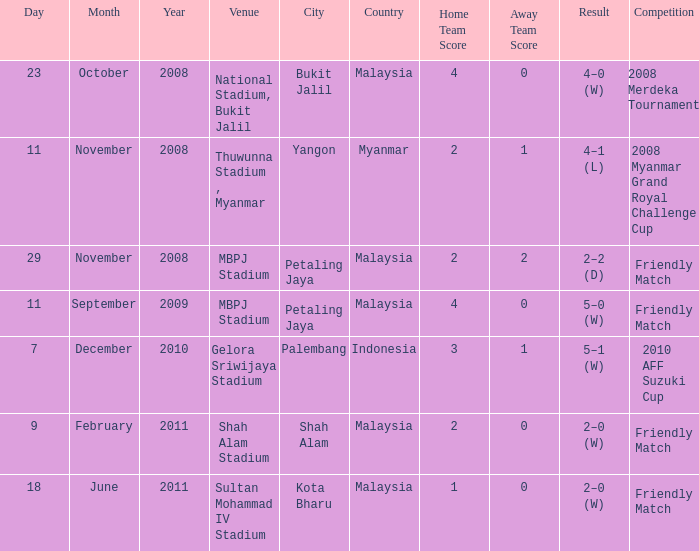What is the Venue of the Competition with a Result of 2–2 (d)? MBPJ Stadium. Could you parse the entire table as a dict? {'header': ['Day', 'Month', 'Year', 'Venue', 'City', 'Country', 'Home Team Score', 'Away Team Score', 'Result', 'Competition'], 'rows': [['23', 'October', '2008', 'National Stadium, Bukit Jalil', 'Bukit Jalil', 'Malaysia', '4', '0', '4–0 (W)', '2008 Merdeka Tournament'], ['11', 'November', '2008', 'Thuwunna Stadium , Myanmar', 'Yangon', 'Myanmar', '2', '1', '4–1 (L)', '2008 Myanmar Grand Royal Challenge Cup'], ['29', 'November', '2008', 'MBPJ Stadium', 'Petaling Jaya', 'Malaysia', '2', '2', '2–2 (D)', 'Friendly Match'], ['11', 'September', '2009', 'MBPJ Stadium', 'Petaling Jaya', 'Malaysia', '4', '0', '5–0 (W)', 'Friendly Match'], ['7', 'December', '2010', 'Gelora Sriwijaya Stadium', 'Palembang', 'Indonesia', '3', '1', '5–1 (W)', '2010 AFF Suzuki Cup'], ['9', 'February', '2011', 'Shah Alam Stadium', 'Shah Alam', 'Malaysia', '2', '0', '2–0 (W)', 'Friendly Match'], ['18', 'June', '2011', 'Sultan Mohammad IV Stadium', 'Kota Bharu', 'Malaysia', '1', '0', '2–0 (W)', 'Friendly Match']]} 